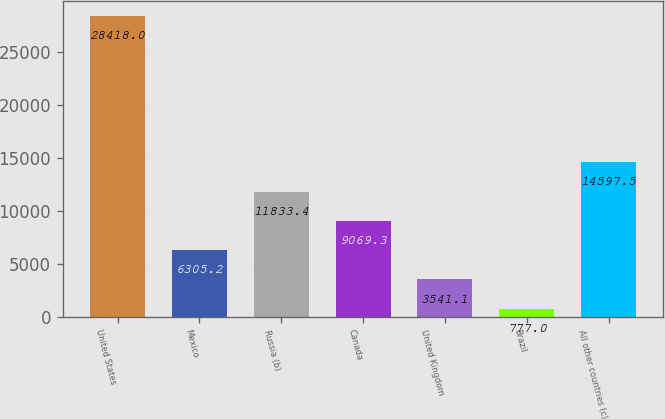Convert chart. <chart><loc_0><loc_0><loc_500><loc_500><bar_chart><fcel>United States<fcel>Mexico<fcel>Russia (b)<fcel>Canada<fcel>United Kingdom<fcel>Brazil<fcel>All other countries (c)<nl><fcel>28418<fcel>6305.2<fcel>11833.4<fcel>9069.3<fcel>3541.1<fcel>777<fcel>14597.5<nl></chart> 